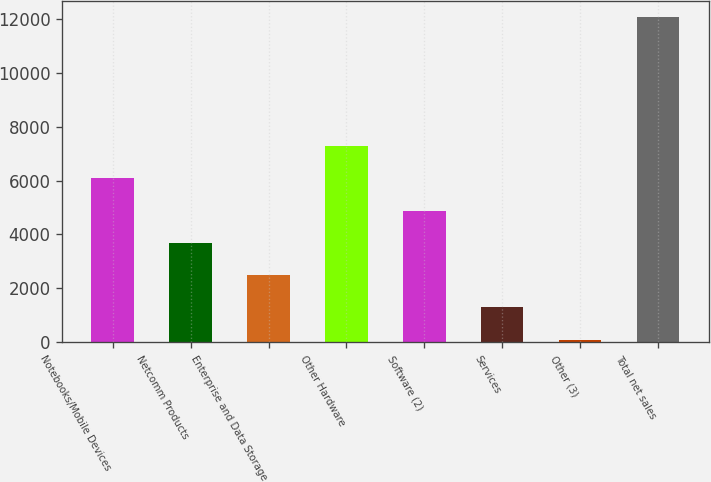Convert chart. <chart><loc_0><loc_0><loc_500><loc_500><bar_chart><fcel>Notebooks/Mobile Devices<fcel>Netcomm Products<fcel>Enterprise and Data Storage<fcel>Other Hardware<fcel>Software (2)<fcel>Services<fcel>Other (3)<fcel>Total net sales<nl><fcel>6085.2<fcel>3689.48<fcel>2491.62<fcel>7283.06<fcel>4887.34<fcel>1293.76<fcel>95.9<fcel>12074.5<nl></chart> 